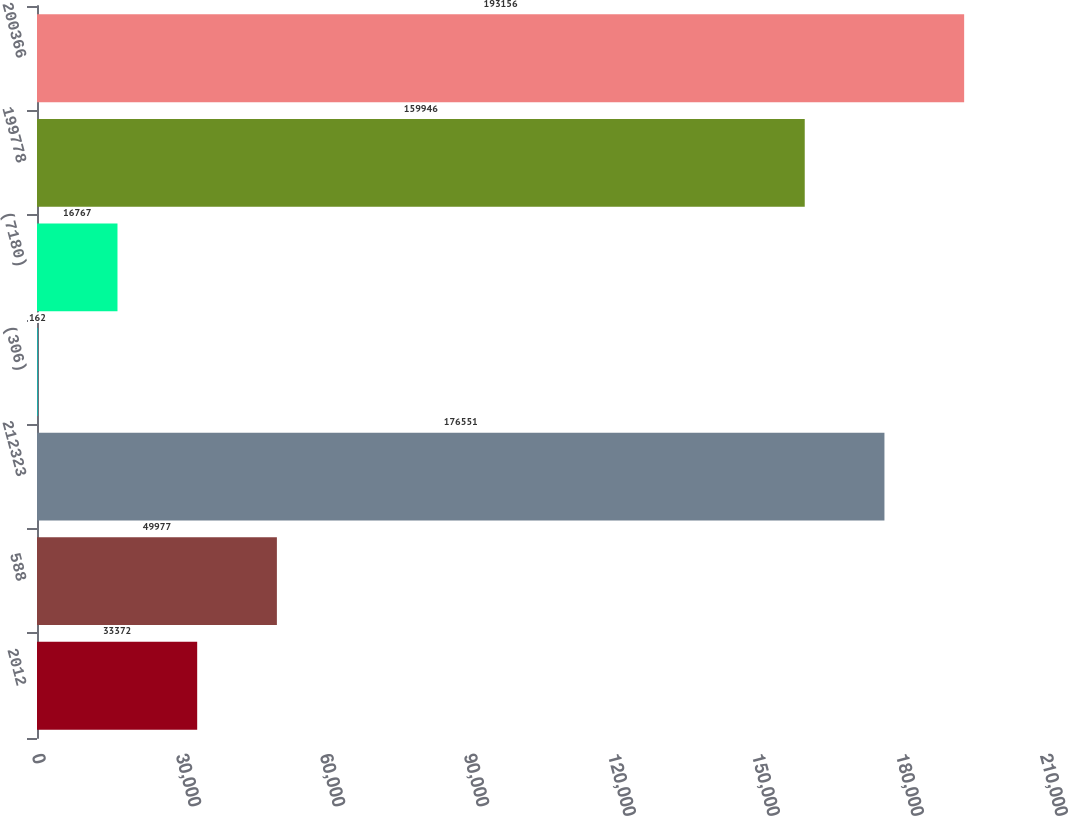Convert chart to OTSL. <chart><loc_0><loc_0><loc_500><loc_500><bar_chart><fcel>2012<fcel>588<fcel>212323<fcel>(306)<fcel>(7180)<fcel>199778<fcel>200366<nl><fcel>33372<fcel>49977<fcel>176551<fcel>162<fcel>16767<fcel>159946<fcel>193156<nl></chart> 